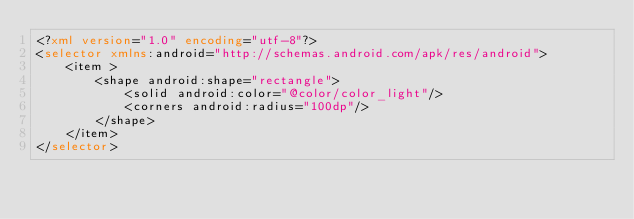Convert code to text. <code><loc_0><loc_0><loc_500><loc_500><_XML_><?xml version="1.0" encoding="utf-8"?>
<selector xmlns:android="http://schemas.android.com/apk/res/android">
    <item >
        <shape android:shape="rectangle">
            <solid android:color="@color/color_light"/>
            <corners android:radius="100dp"/>
        </shape>
    </item>
</selector></code> 